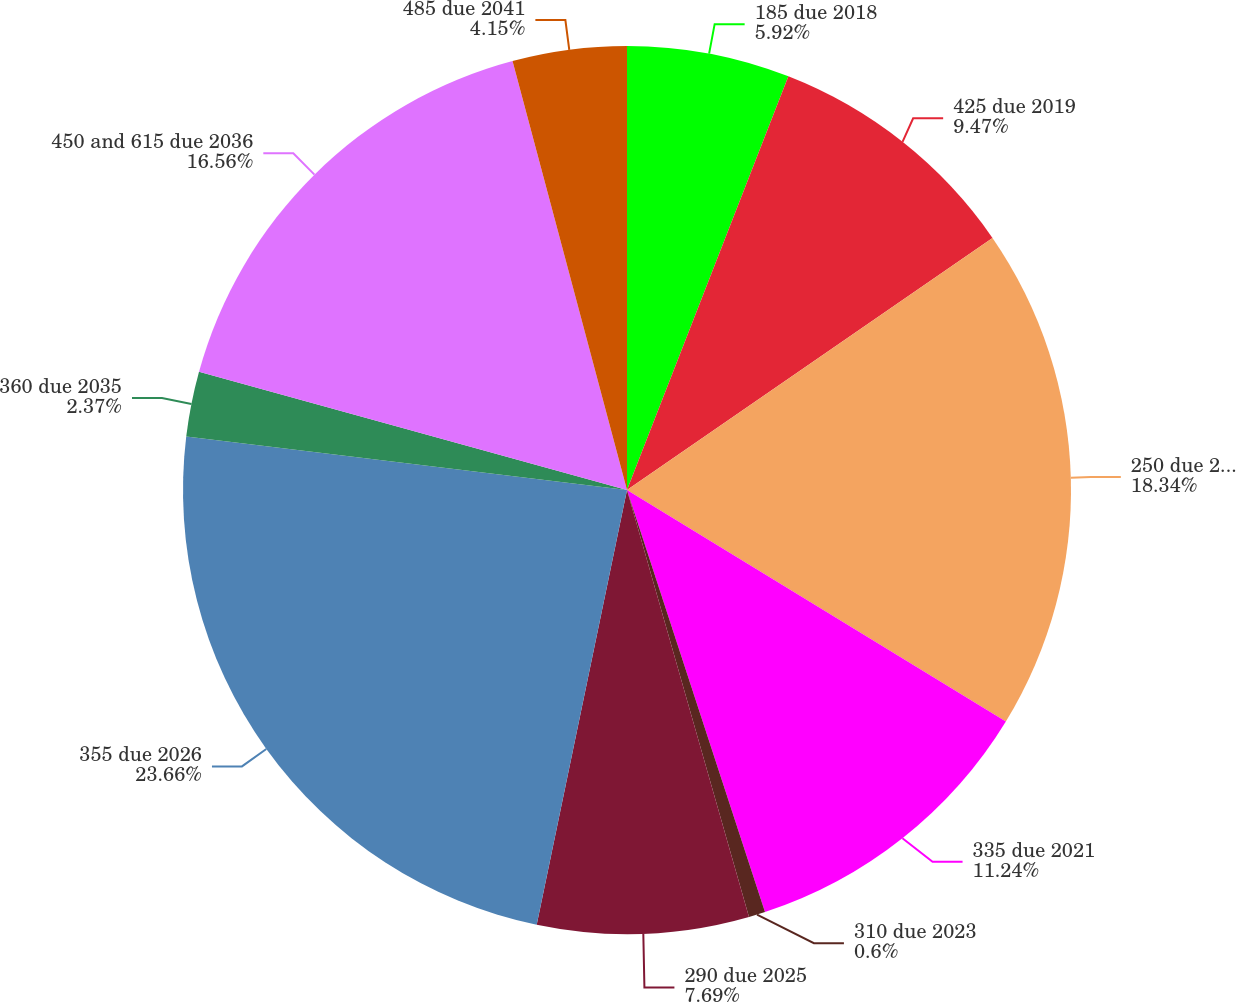Convert chart. <chart><loc_0><loc_0><loc_500><loc_500><pie_chart><fcel>185 due 2018<fcel>425 due 2019<fcel>250 due 2020<fcel>335 due 2021<fcel>310 due 2023<fcel>290 due 2025<fcel>355 due 2026<fcel>360 due 2035<fcel>450 and 615 due 2036<fcel>485 due 2041<nl><fcel>5.92%<fcel>9.47%<fcel>18.34%<fcel>11.24%<fcel>0.6%<fcel>7.69%<fcel>23.66%<fcel>2.37%<fcel>16.56%<fcel>4.15%<nl></chart> 